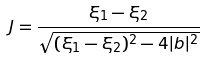<formula> <loc_0><loc_0><loc_500><loc_500>J = { \frac { \xi _ { 1 } - \xi _ { 2 } } { \sqrt { ( \xi _ { 1 } - \xi _ { 2 } ) ^ { 2 } - 4 | b | ^ { 2 } } } }</formula> 